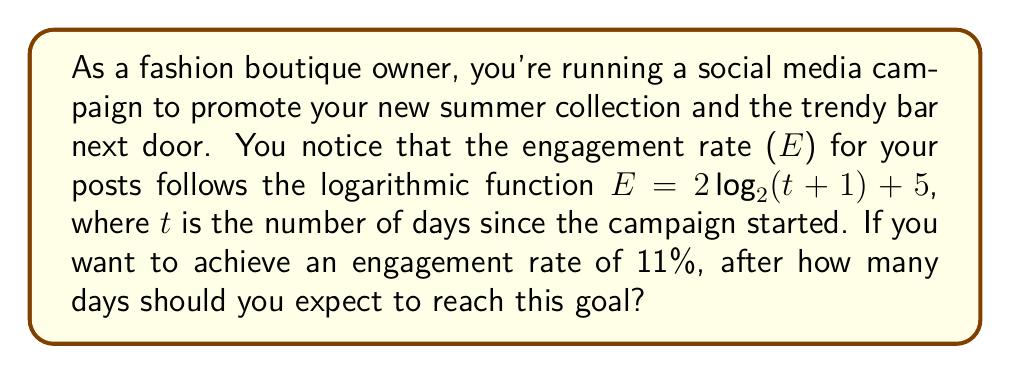Teach me how to tackle this problem. Let's approach this step-by-step:

1) We're given the function $E = 2\log_2(t+1) + 5$, where E is the engagement rate and t is the number of days.

2) We want to find t when E = 11% = 0.11

3) Let's substitute this into our equation:
   $0.11 = 2\log_2(t+1) + 5$

4) Subtract 5 from both sides:
   $-4.89 = 2\log_2(t+1)$

5) Divide both sides by 2:
   $-2.445 = \log_2(t+1)$

6) Now, we need to solve for t. We can do this by applying $2^x$ to both sides:
   $2^{-2.445} = t+1$

7) Calculate $2^{-2.445}$:
   $0.183 = t+1$

8) Subtract 1 from both sides:
   $-0.817 = t$

9) Since time can't be negative, and we need to round up to the next whole day, our answer is 0 days.

This means the engagement rate is already above 11% at the start of the campaign.
Answer: 0 days 